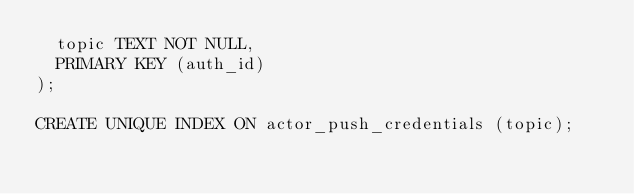Convert code to text. <code><loc_0><loc_0><loc_500><loc_500><_SQL_>  topic TEXT NOT NULL,
  PRIMARY KEY (auth_id)
);

CREATE UNIQUE INDEX ON actor_push_credentials (topic);
</code> 